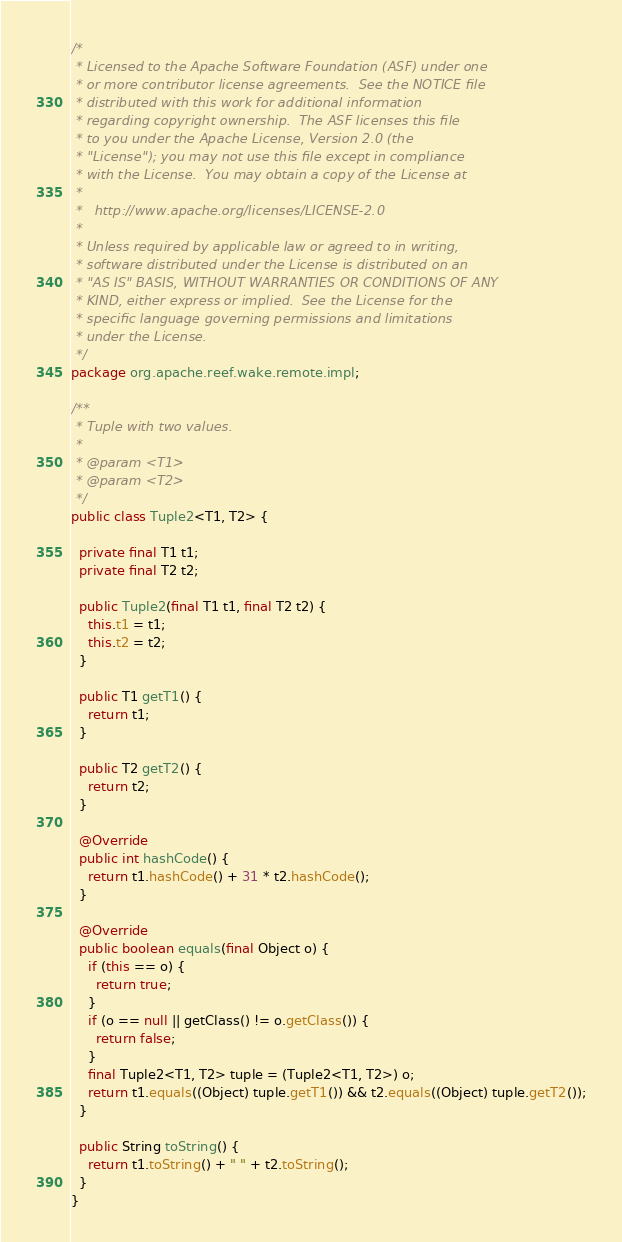Convert code to text. <code><loc_0><loc_0><loc_500><loc_500><_Java_>/*
 * Licensed to the Apache Software Foundation (ASF) under one
 * or more contributor license agreements.  See the NOTICE file
 * distributed with this work for additional information
 * regarding copyright ownership.  The ASF licenses this file
 * to you under the Apache License, Version 2.0 (the
 * "License"); you may not use this file except in compliance
 * with the License.  You may obtain a copy of the License at
 *
 *   http://www.apache.org/licenses/LICENSE-2.0
 *
 * Unless required by applicable law or agreed to in writing,
 * software distributed under the License is distributed on an
 * "AS IS" BASIS, WITHOUT WARRANTIES OR CONDITIONS OF ANY
 * KIND, either express or implied.  See the License for the
 * specific language governing permissions and limitations
 * under the License.
 */
package org.apache.reef.wake.remote.impl;

/**
 * Tuple with two values.
 *
 * @param <T1>
 * @param <T2>
 */
public class Tuple2<T1, T2> {

  private final T1 t1;
  private final T2 t2;

  public Tuple2(final T1 t1, final T2 t2) {
    this.t1 = t1;
    this.t2 = t2;
  }

  public T1 getT1() {
    return t1;
  }

  public T2 getT2() {
    return t2;
  }

  @Override
  public int hashCode() {
    return t1.hashCode() + 31 * t2.hashCode();
  }

  @Override
  public boolean equals(final Object o) {
    if (this == o) {
      return true;
    }
    if (o == null || getClass() != o.getClass()) {
      return false;
    }
    final Tuple2<T1, T2> tuple = (Tuple2<T1, T2>) o;
    return t1.equals((Object) tuple.getT1()) && t2.equals((Object) tuple.getT2());
  }

  public String toString() {
    return t1.toString() + " " + t2.toString();
  }
}
</code> 